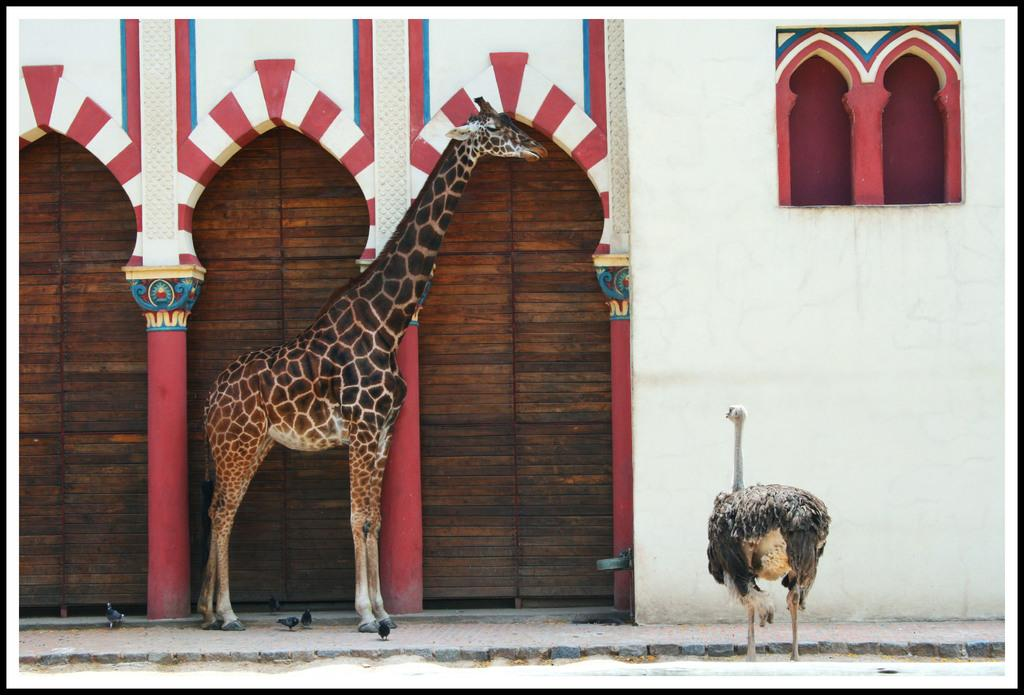What animals can be seen in the image? There is a giraffe and an ostrich in the image. What are the positions of the animals in the image? Both the giraffe and ostrich are standing. What type of structure is present in the image? There appears to be a building in the image. What material do the doors of the building seem to be made of? The doors of the building seem to be made of wood. What other living creatures can be seen in the image? Small birds are visible in the image. What type of winter clothing is the giraffe wearing in the image? There is no winter clothing present in the image, as it features a giraffe and an ostrich in a natural setting. 